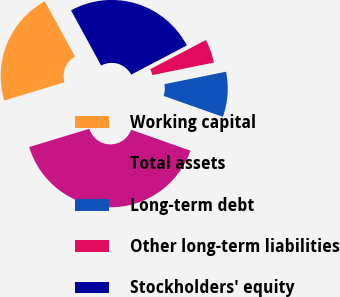<chart> <loc_0><loc_0><loc_500><loc_500><pie_chart><fcel>Working capital<fcel>Total assets<fcel>Long-term debt<fcel>Other long-term liabilities<fcel>Stockholders' equity<nl><fcel>21.73%<fcel>39.91%<fcel>8.59%<fcel>4.5%<fcel>25.27%<nl></chart> 